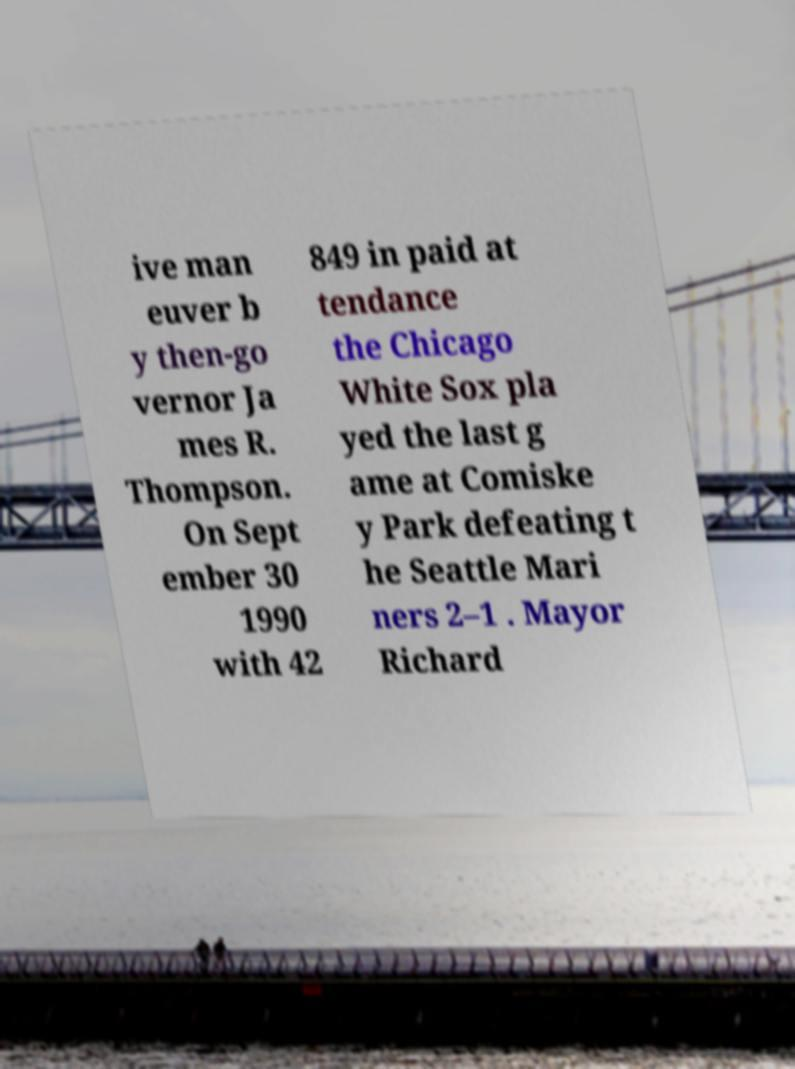Can you accurately transcribe the text from the provided image for me? ive man euver b y then-go vernor Ja mes R. Thompson. On Sept ember 30 1990 with 42 849 in paid at tendance the Chicago White Sox pla yed the last g ame at Comiske y Park defeating t he Seattle Mari ners 2–1 . Mayor Richard 